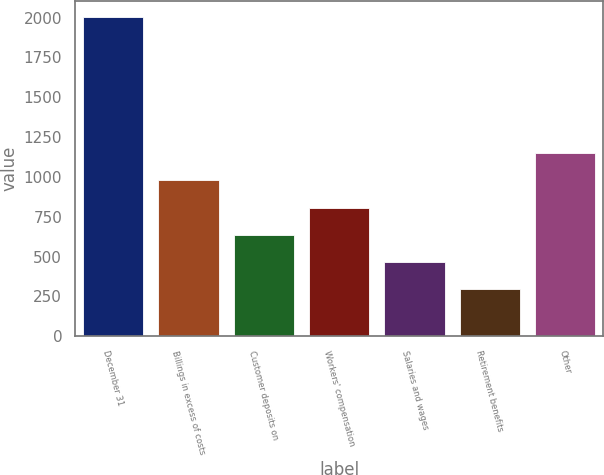<chart> <loc_0><loc_0><loc_500><loc_500><bar_chart><fcel>December 31<fcel>Billings in excess of costs<fcel>Customer deposits on<fcel>Workers' compensation<fcel>Salaries and wages<fcel>Retirement benefits<fcel>Other<nl><fcel>2003<fcel>978.2<fcel>636.6<fcel>807.4<fcel>465.8<fcel>295<fcel>1149<nl></chart> 